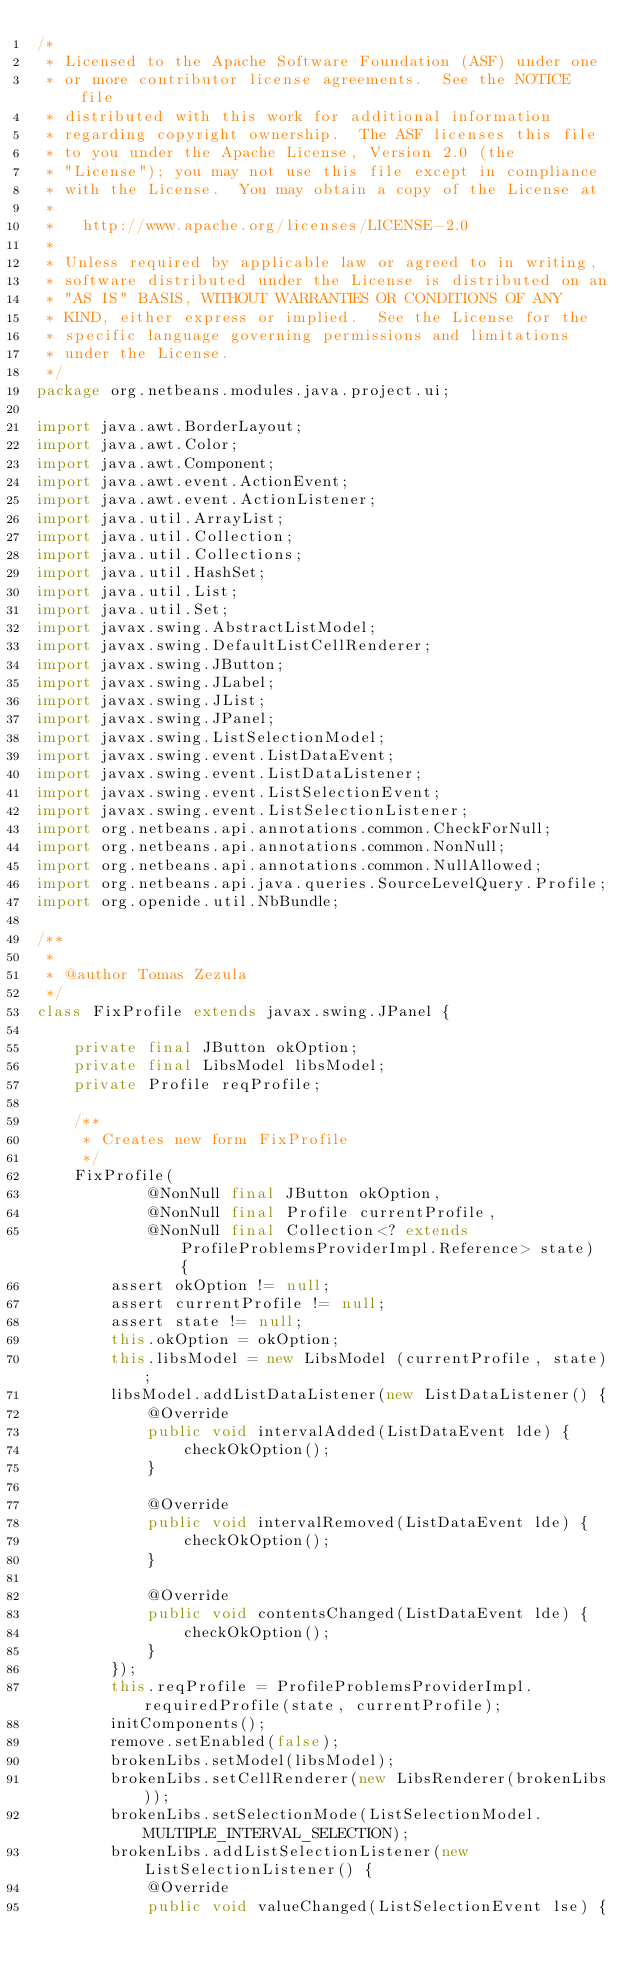Convert code to text. <code><loc_0><loc_0><loc_500><loc_500><_Java_>/*
 * Licensed to the Apache Software Foundation (ASF) under one
 * or more contributor license agreements.  See the NOTICE file
 * distributed with this work for additional information
 * regarding copyright ownership.  The ASF licenses this file
 * to you under the Apache License, Version 2.0 (the
 * "License"); you may not use this file except in compliance
 * with the License.  You may obtain a copy of the License at
 *
 *   http://www.apache.org/licenses/LICENSE-2.0
 *
 * Unless required by applicable law or agreed to in writing,
 * software distributed under the License is distributed on an
 * "AS IS" BASIS, WITHOUT WARRANTIES OR CONDITIONS OF ANY
 * KIND, either express or implied.  See the License for the
 * specific language governing permissions and limitations
 * under the License.
 */
package org.netbeans.modules.java.project.ui;

import java.awt.BorderLayout;
import java.awt.Color;
import java.awt.Component;
import java.awt.event.ActionEvent;
import java.awt.event.ActionListener;
import java.util.ArrayList;
import java.util.Collection;
import java.util.Collections;
import java.util.HashSet;
import java.util.List;
import java.util.Set;
import javax.swing.AbstractListModel;
import javax.swing.DefaultListCellRenderer;
import javax.swing.JButton;
import javax.swing.JLabel;
import javax.swing.JList;
import javax.swing.JPanel;
import javax.swing.ListSelectionModel;
import javax.swing.event.ListDataEvent;
import javax.swing.event.ListDataListener;
import javax.swing.event.ListSelectionEvent;
import javax.swing.event.ListSelectionListener;
import org.netbeans.api.annotations.common.CheckForNull;
import org.netbeans.api.annotations.common.NonNull;
import org.netbeans.api.annotations.common.NullAllowed;
import org.netbeans.api.java.queries.SourceLevelQuery.Profile;
import org.openide.util.NbBundle;

/**
 *
 * @author Tomas Zezula
 */
class FixProfile extends javax.swing.JPanel {
 
    private final JButton okOption;
    private final LibsModel libsModel;
    private Profile reqProfile;

    /**
     * Creates new form FixProfile
     */
    FixProfile(
            @NonNull final JButton okOption,
            @NonNull final Profile currentProfile,
            @NonNull final Collection<? extends ProfileProblemsProviderImpl.Reference> state) {
        assert okOption != null;
        assert currentProfile != null;
        assert state != null;
        this.okOption = okOption;
        this.libsModel = new LibsModel (currentProfile, state);
        libsModel.addListDataListener(new ListDataListener() {
            @Override
            public void intervalAdded(ListDataEvent lde) {
                checkOkOption();
            }

            @Override
            public void intervalRemoved(ListDataEvent lde) {
                checkOkOption();
            }

            @Override
            public void contentsChanged(ListDataEvent lde) {
                checkOkOption();
            }
        });
        this.reqProfile = ProfileProblemsProviderImpl.requiredProfile(state, currentProfile);
        initComponents();
        remove.setEnabled(false);
        brokenLibs.setModel(libsModel);
        brokenLibs.setCellRenderer(new LibsRenderer(brokenLibs));
        brokenLibs.setSelectionMode(ListSelectionModel.MULTIPLE_INTERVAL_SELECTION);
        brokenLibs.addListSelectionListener(new ListSelectionListener() {
            @Override
            public void valueChanged(ListSelectionEvent lse) {</code> 